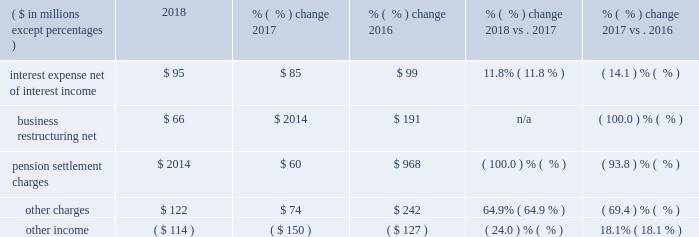30 2018 ppg annual report and 10-k foreign currency translation partially offset by : cost reclassifications associated with the adoption of the new revenue recognition standard .
Refer to note 2 , "revenue recognition" within part 2 of this form 10-k cost management including restructuring cost savings 2017 vs .
2016 selling , general and administrative expenses decreased $ 1 million primarily due to : lower net periodic pension and other postretirement benefit costs lower selling and advertising costs restructuring cost savings partially offset by : wage and other cost inflation selling , general and administrative expenses from acquired businesses foreign currency translation other charges and other income .
Interest expense , net of interest income interest expense , net of interest income increased $ 10 million in 2018 versus 2017 primarily due to the issuance of long- term debt in early 2018 .
Interest expense , net of interest income decreased $ 14 million in 2017 versus 2016 due to lower interest rate debt outstanding in 2017 .
Business restructuring , net a pretax restructuring charge of $ 83 million was recorded in the second quarter of 2018 , offset by certain changes in estimates to complete previously recorded programs of $ 17 million .
A pretax charge of $ 191 million was recorded in 2016 .
Refer to note 8 , "business restructuring" in item 8 of this form 10-k for additional information .
Pension settlement charges during 2017 , ppg made lump-sum payments to certain retirees who had participated in ppg's u.s .
Qualified and non- qualified pension plans totaling approximately $ 127 million .
As the lump-sum payments were in excess of the expected 2017 service and interest costs for the affected plans , ppg remeasured the periodic benefit obligation of these plans in the period payments were made and recorded settlement charges totaling $ 60 million ( $ 38 million after-tax ) during 2017 .
During 2016 , ppg permanently transferred approximately $ 1.8 billion of its u.s .
And canadian pension obligations and assets to several highly rated insurance companies .
These actions triggered remeasurement and partial settlement of certain of the company 2019s defined benefit pension plans .
Ppg recognized a $ 968 million pre-tax settlement charge in connection with these transactions .
Refer to note 13 , "employee benefit plans" in item 8 of this form 10-k for additional information .
Other charges other charges in 2018 and 2016 were higher than 2017 primarily due to environmental remediation charges .
These charges were principally for environmental remediation at a former chromium manufacturing plant and associated sites in new jersey .
Refer to note 14 , "commitments and contingent liabilities" in item 8 of this form 10-k for additional information .
Other income other income was lower in 2018 and 2016 than in 2017 primarily due to the gain from the sale of the mexican plaka business of $ 25 million and income from a legal settlement of $ 18 million in 2017 .
Refer to note 3 , "acquisitions and divestitures" in item 8 of this form 10-k for additional information. .
Assuming the same change in net interest expense in 2019 as occurred in 2018 , what would the 2019 expense be , in millions? 
Computations: ((95 - 85) + 95)
Answer: 105.0. 30 2018 ppg annual report and 10-k foreign currency translation partially offset by : cost reclassifications associated with the adoption of the new revenue recognition standard .
Refer to note 2 , "revenue recognition" within part 2 of this form 10-k cost management including restructuring cost savings 2017 vs .
2016 selling , general and administrative expenses decreased $ 1 million primarily due to : lower net periodic pension and other postretirement benefit costs lower selling and advertising costs restructuring cost savings partially offset by : wage and other cost inflation selling , general and administrative expenses from acquired businesses foreign currency translation other charges and other income .
Interest expense , net of interest income interest expense , net of interest income increased $ 10 million in 2018 versus 2017 primarily due to the issuance of long- term debt in early 2018 .
Interest expense , net of interest income decreased $ 14 million in 2017 versus 2016 due to lower interest rate debt outstanding in 2017 .
Business restructuring , net a pretax restructuring charge of $ 83 million was recorded in the second quarter of 2018 , offset by certain changes in estimates to complete previously recorded programs of $ 17 million .
A pretax charge of $ 191 million was recorded in 2016 .
Refer to note 8 , "business restructuring" in item 8 of this form 10-k for additional information .
Pension settlement charges during 2017 , ppg made lump-sum payments to certain retirees who had participated in ppg's u.s .
Qualified and non- qualified pension plans totaling approximately $ 127 million .
As the lump-sum payments were in excess of the expected 2017 service and interest costs for the affected plans , ppg remeasured the periodic benefit obligation of these plans in the period payments were made and recorded settlement charges totaling $ 60 million ( $ 38 million after-tax ) during 2017 .
During 2016 , ppg permanently transferred approximately $ 1.8 billion of its u.s .
And canadian pension obligations and assets to several highly rated insurance companies .
These actions triggered remeasurement and partial settlement of certain of the company 2019s defined benefit pension plans .
Ppg recognized a $ 968 million pre-tax settlement charge in connection with these transactions .
Refer to note 13 , "employee benefit plans" in item 8 of this form 10-k for additional information .
Other charges other charges in 2018 and 2016 were higher than 2017 primarily due to environmental remediation charges .
These charges were principally for environmental remediation at a former chromium manufacturing plant and associated sites in new jersey .
Refer to note 14 , "commitments and contingent liabilities" in item 8 of this form 10-k for additional information .
Other income other income was lower in 2018 and 2016 than in 2017 primarily due to the gain from the sale of the mexican plaka business of $ 25 million and income from a legal settlement of $ 18 million in 2017 .
Refer to note 3 , "acquisitions and divestitures" in item 8 of this form 10-k for additional information. .
What was the total pre-tax restructuring program cost in millions? 
Computations: ((83 - 17) + 191)
Answer: 257.0. 